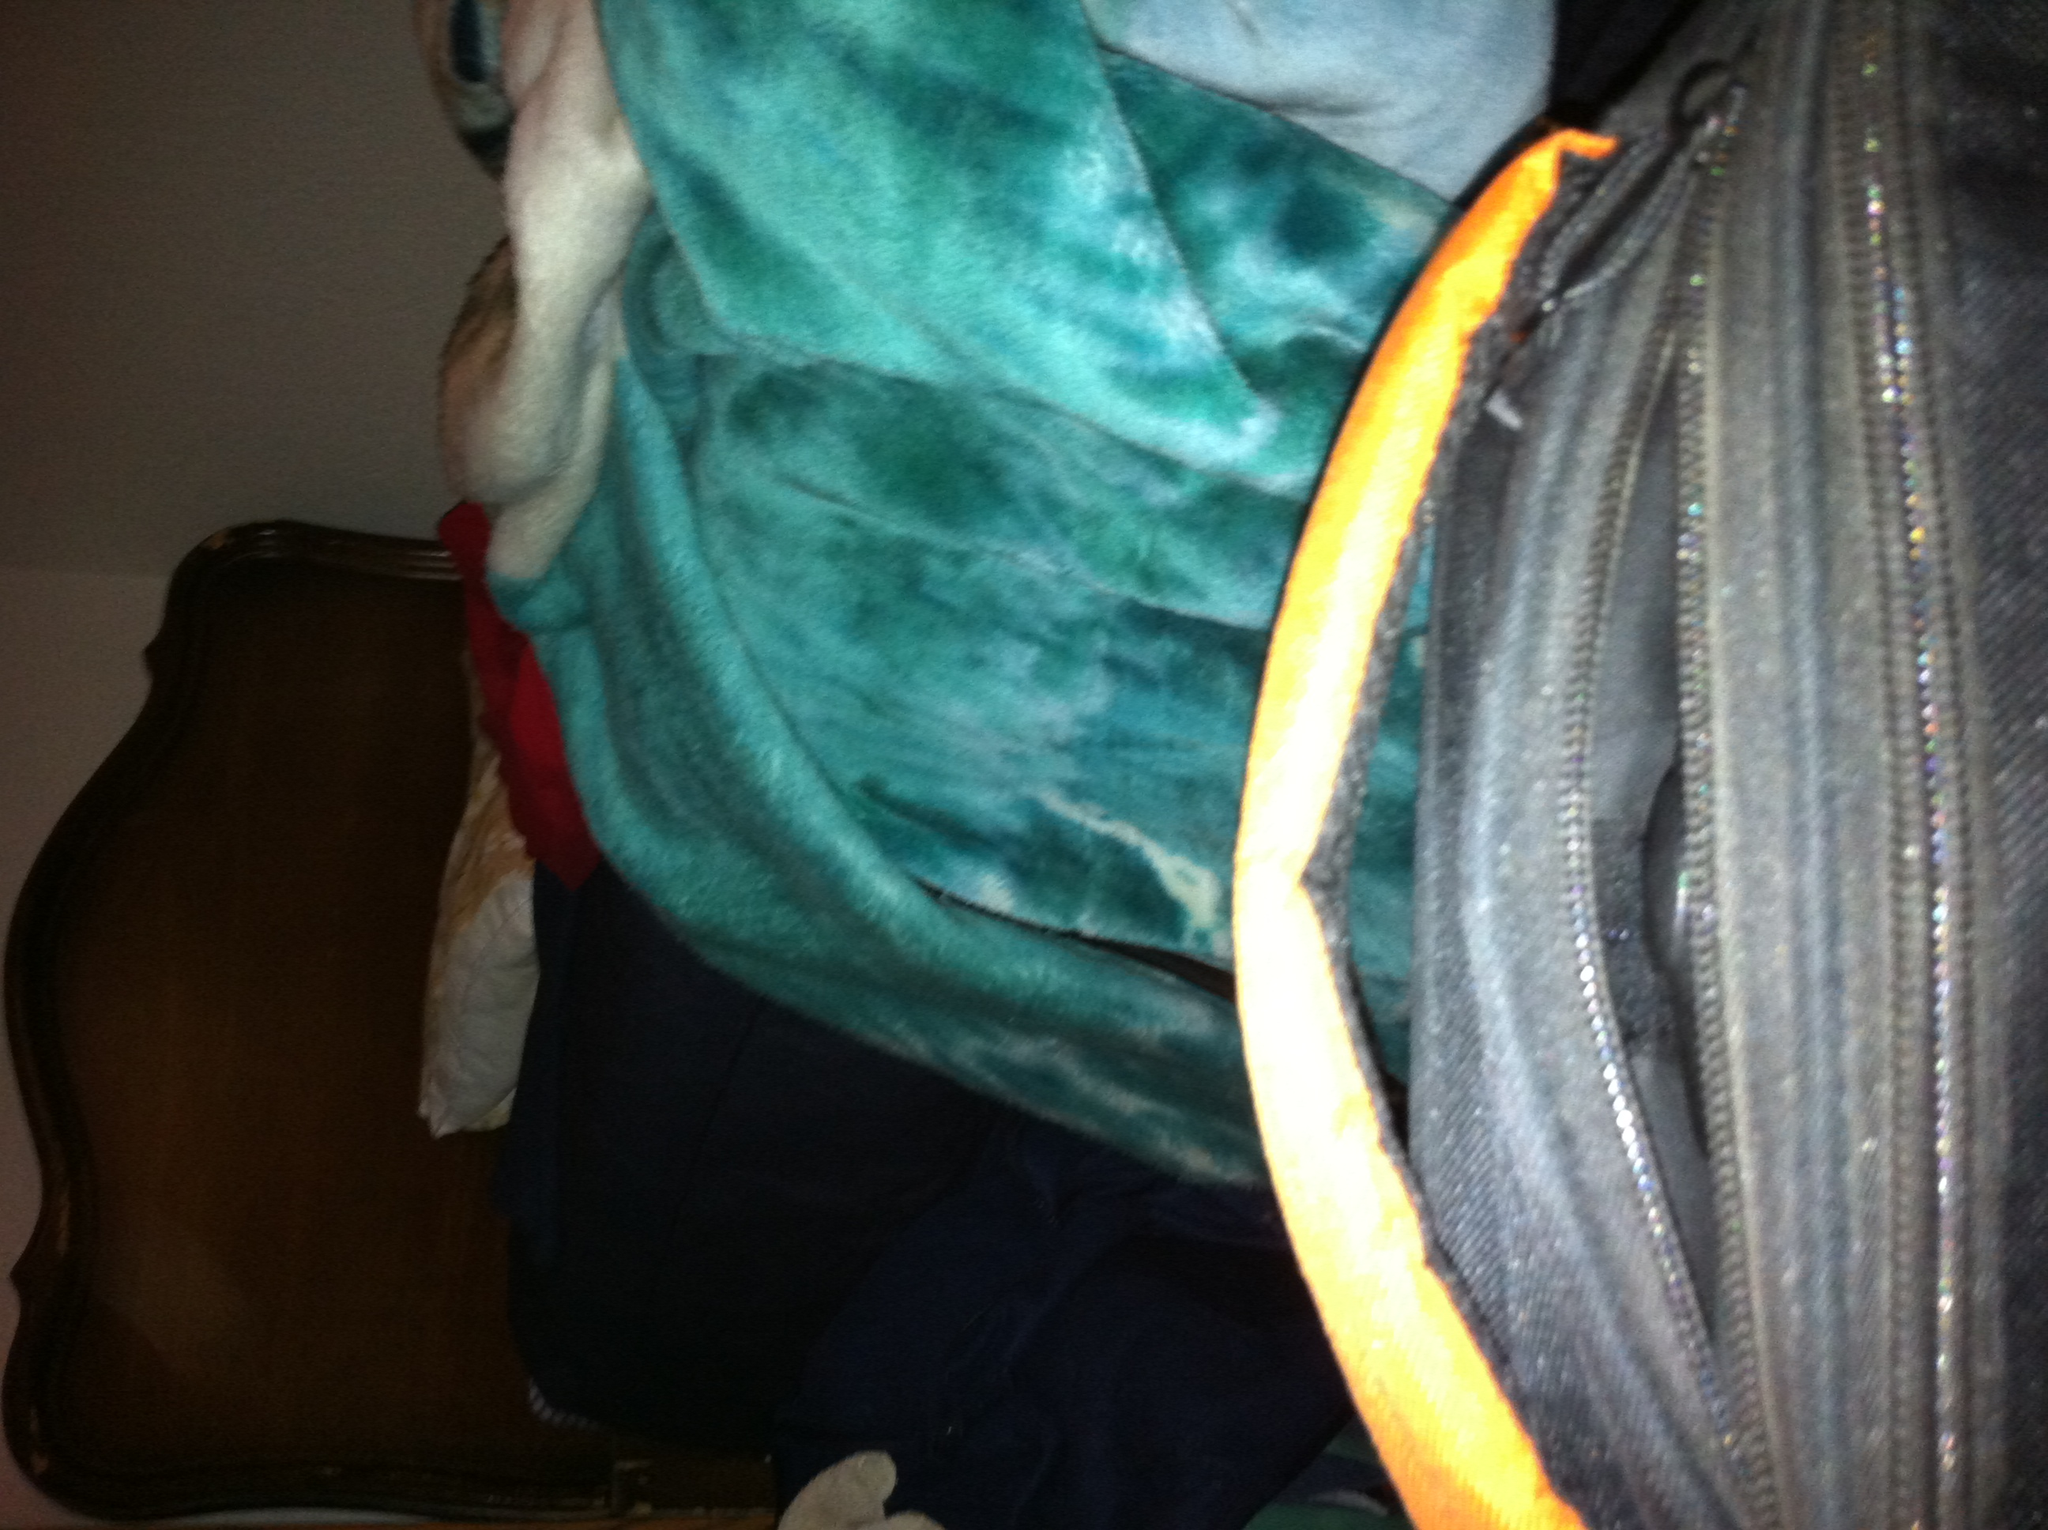Is the bag suitable for formal occasions? Given its casual design and durable fabric, this black bag is more suited for casual use or everyday tasks rather than formal occasions. 